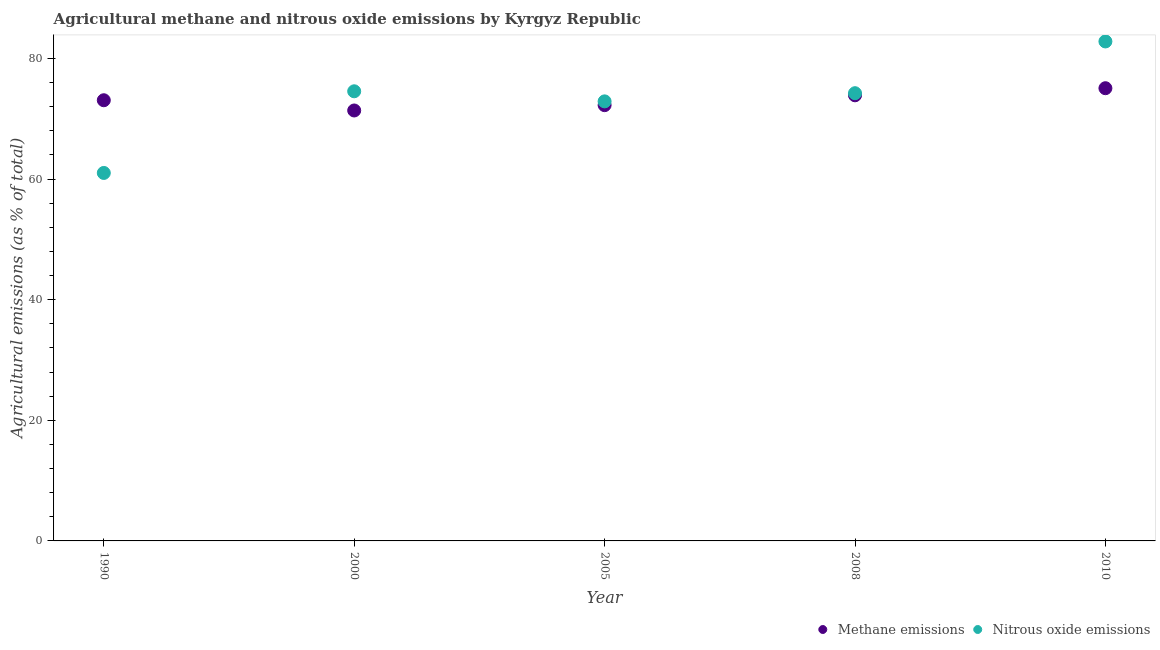Is the number of dotlines equal to the number of legend labels?
Offer a terse response. Yes. What is the amount of methane emissions in 2000?
Offer a very short reply. 71.37. Across all years, what is the maximum amount of methane emissions?
Make the answer very short. 75.07. Across all years, what is the minimum amount of nitrous oxide emissions?
Offer a very short reply. 61.01. In which year was the amount of methane emissions maximum?
Ensure brevity in your answer.  2010. What is the total amount of nitrous oxide emissions in the graph?
Your answer should be very brief. 365.51. What is the difference between the amount of methane emissions in 2005 and that in 2010?
Your answer should be very brief. -2.81. What is the difference between the amount of nitrous oxide emissions in 1990 and the amount of methane emissions in 2005?
Keep it short and to the point. -11.24. What is the average amount of nitrous oxide emissions per year?
Your response must be concise. 73.1. In the year 2010, what is the difference between the amount of methane emissions and amount of nitrous oxide emissions?
Your response must be concise. -7.75. In how many years, is the amount of methane emissions greater than 52 %?
Give a very brief answer. 5. What is the ratio of the amount of methane emissions in 1990 to that in 2000?
Provide a short and direct response. 1.02. Is the amount of methane emissions in 1990 less than that in 2010?
Offer a very short reply. Yes. Is the difference between the amount of methane emissions in 2000 and 2010 greater than the difference between the amount of nitrous oxide emissions in 2000 and 2010?
Offer a terse response. Yes. What is the difference between the highest and the second highest amount of nitrous oxide emissions?
Your response must be concise. 8.26. What is the difference between the highest and the lowest amount of nitrous oxide emissions?
Ensure brevity in your answer.  21.8. Is the sum of the amount of methane emissions in 2000 and 2008 greater than the maximum amount of nitrous oxide emissions across all years?
Offer a very short reply. Yes. How many years are there in the graph?
Provide a short and direct response. 5. Are the values on the major ticks of Y-axis written in scientific E-notation?
Offer a terse response. No. Does the graph contain grids?
Keep it short and to the point. No. How many legend labels are there?
Give a very brief answer. 2. What is the title of the graph?
Offer a very short reply. Agricultural methane and nitrous oxide emissions by Kyrgyz Republic. Does "Personal remittances" appear as one of the legend labels in the graph?
Provide a succinct answer. No. What is the label or title of the X-axis?
Make the answer very short. Year. What is the label or title of the Y-axis?
Ensure brevity in your answer.  Agricultural emissions (as % of total). What is the Agricultural emissions (as % of total) of Methane emissions in 1990?
Provide a succinct answer. 73.07. What is the Agricultural emissions (as % of total) in Nitrous oxide emissions in 1990?
Give a very brief answer. 61.01. What is the Agricultural emissions (as % of total) in Methane emissions in 2000?
Your response must be concise. 71.37. What is the Agricultural emissions (as % of total) in Nitrous oxide emissions in 2000?
Ensure brevity in your answer.  74.56. What is the Agricultural emissions (as % of total) of Methane emissions in 2005?
Your answer should be very brief. 72.26. What is the Agricultural emissions (as % of total) of Nitrous oxide emissions in 2005?
Ensure brevity in your answer.  72.88. What is the Agricultural emissions (as % of total) in Methane emissions in 2008?
Offer a terse response. 73.89. What is the Agricultural emissions (as % of total) of Nitrous oxide emissions in 2008?
Provide a short and direct response. 74.24. What is the Agricultural emissions (as % of total) of Methane emissions in 2010?
Make the answer very short. 75.07. What is the Agricultural emissions (as % of total) of Nitrous oxide emissions in 2010?
Keep it short and to the point. 82.82. Across all years, what is the maximum Agricultural emissions (as % of total) in Methane emissions?
Make the answer very short. 75.07. Across all years, what is the maximum Agricultural emissions (as % of total) of Nitrous oxide emissions?
Make the answer very short. 82.82. Across all years, what is the minimum Agricultural emissions (as % of total) in Methane emissions?
Give a very brief answer. 71.37. Across all years, what is the minimum Agricultural emissions (as % of total) in Nitrous oxide emissions?
Offer a terse response. 61.01. What is the total Agricultural emissions (as % of total) of Methane emissions in the graph?
Ensure brevity in your answer.  365.66. What is the total Agricultural emissions (as % of total) of Nitrous oxide emissions in the graph?
Provide a succinct answer. 365.51. What is the difference between the Agricultural emissions (as % of total) in Methane emissions in 1990 and that in 2000?
Provide a succinct answer. 1.7. What is the difference between the Agricultural emissions (as % of total) of Nitrous oxide emissions in 1990 and that in 2000?
Your response must be concise. -13.54. What is the difference between the Agricultural emissions (as % of total) of Methane emissions in 1990 and that in 2005?
Keep it short and to the point. 0.81. What is the difference between the Agricultural emissions (as % of total) of Nitrous oxide emissions in 1990 and that in 2005?
Make the answer very short. -11.87. What is the difference between the Agricultural emissions (as % of total) of Methane emissions in 1990 and that in 2008?
Make the answer very short. -0.82. What is the difference between the Agricultural emissions (as % of total) in Nitrous oxide emissions in 1990 and that in 2008?
Offer a very short reply. -13.22. What is the difference between the Agricultural emissions (as % of total) in Methane emissions in 1990 and that in 2010?
Offer a very short reply. -2. What is the difference between the Agricultural emissions (as % of total) of Nitrous oxide emissions in 1990 and that in 2010?
Provide a succinct answer. -21.8. What is the difference between the Agricultural emissions (as % of total) in Methane emissions in 2000 and that in 2005?
Make the answer very short. -0.89. What is the difference between the Agricultural emissions (as % of total) in Nitrous oxide emissions in 2000 and that in 2005?
Offer a very short reply. 1.67. What is the difference between the Agricultural emissions (as % of total) in Methane emissions in 2000 and that in 2008?
Give a very brief answer. -2.52. What is the difference between the Agricultural emissions (as % of total) in Nitrous oxide emissions in 2000 and that in 2008?
Ensure brevity in your answer.  0.32. What is the difference between the Agricultural emissions (as % of total) of Methane emissions in 2000 and that in 2010?
Provide a short and direct response. -3.69. What is the difference between the Agricultural emissions (as % of total) in Nitrous oxide emissions in 2000 and that in 2010?
Offer a very short reply. -8.26. What is the difference between the Agricultural emissions (as % of total) of Methane emissions in 2005 and that in 2008?
Keep it short and to the point. -1.63. What is the difference between the Agricultural emissions (as % of total) of Nitrous oxide emissions in 2005 and that in 2008?
Make the answer very short. -1.35. What is the difference between the Agricultural emissions (as % of total) of Methane emissions in 2005 and that in 2010?
Your response must be concise. -2.81. What is the difference between the Agricultural emissions (as % of total) of Nitrous oxide emissions in 2005 and that in 2010?
Your answer should be very brief. -9.93. What is the difference between the Agricultural emissions (as % of total) in Methane emissions in 2008 and that in 2010?
Your response must be concise. -1.18. What is the difference between the Agricultural emissions (as % of total) in Nitrous oxide emissions in 2008 and that in 2010?
Provide a succinct answer. -8.58. What is the difference between the Agricultural emissions (as % of total) in Methane emissions in 1990 and the Agricultural emissions (as % of total) in Nitrous oxide emissions in 2000?
Your answer should be compact. -1.49. What is the difference between the Agricultural emissions (as % of total) in Methane emissions in 1990 and the Agricultural emissions (as % of total) in Nitrous oxide emissions in 2005?
Ensure brevity in your answer.  0.19. What is the difference between the Agricultural emissions (as % of total) of Methane emissions in 1990 and the Agricultural emissions (as % of total) of Nitrous oxide emissions in 2008?
Ensure brevity in your answer.  -1.17. What is the difference between the Agricultural emissions (as % of total) in Methane emissions in 1990 and the Agricultural emissions (as % of total) in Nitrous oxide emissions in 2010?
Give a very brief answer. -9.75. What is the difference between the Agricultural emissions (as % of total) in Methane emissions in 2000 and the Agricultural emissions (as % of total) in Nitrous oxide emissions in 2005?
Your answer should be very brief. -1.51. What is the difference between the Agricultural emissions (as % of total) in Methane emissions in 2000 and the Agricultural emissions (as % of total) in Nitrous oxide emissions in 2008?
Your answer should be very brief. -2.87. What is the difference between the Agricultural emissions (as % of total) in Methane emissions in 2000 and the Agricultural emissions (as % of total) in Nitrous oxide emissions in 2010?
Your answer should be very brief. -11.45. What is the difference between the Agricultural emissions (as % of total) in Methane emissions in 2005 and the Agricultural emissions (as % of total) in Nitrous oxide emissions in 2008?
Keep it short and to the point. -1.98. What is the difference between the Agricultural emissions (as % of total) of Methane emissions in 2005 and the Agricultural emissions (as % of total) of Nitrous oxide emissions in 2010?
Make the answer very short. -10.56. What is the difference between the Agricultural emissions (as % of total) in Methane emissions in 2008 and the Agricultural emissions (as % of total) in Nitrous oxide emissions in 2010?
Offer a terse response. -8.93. What is the average Agricultural emissions (as % of total) of Methane emissions per year?
Your response must be concise. 73.13. What is the average Agricultural emissions (as % of total) of Nitrous oxide emissions per year?
Offer a very short reply. 73.1. In the year 1990, what is the difference between the Agricultural emissions (as % of total) in Methane emissions and Agricultural emissions (as % of total) in Nitrous oxide emissions?
Your answer should be compact. 12.06. In the year 2000, what is the difference between the Agricultural emissions (as % of total) in Methane emissions and Agricultural emissions (as % of total) in Nitrous oxide emissions?
Your response must be concise. -3.18. In the year 2005, what is the difference between the Agricultural emissions (as % of total) of Methane emissions and Agricultural emissions (as % of total) of Nitrous oxide emissions?
Provide a succinct answer. -0.63. In the year 2008, what is the difference between the Agricultural emissions (as % of total) in Methane emissions and Agricultural emissions (as % of total) in Nitrous oxide emissions?
Keep it short and to the point. -0.35. In the year 2010, what is the difference between the Agricultural emissions (as % of total) in Methane emissions and Agricultural emissions (as % of total) in Nitrous oxide emissions?
Ensure brevity in your answer.  -7.75. What is the ratio of the Agricultural emissions (as % of total) in Methane emissions in 1990 to that in 2000?
Offer a terse response. 1.02. What is the ratio of the Agricultural emissions (as % of total) of Nitrous oxide emissions in 1990 to that in 2000?
Provide a short and direct response. 0.82. What is the ratio of the Agricultural emissions (as % of total) in Methane emissions in 1990 to that in 2005?
Provide a succinct answer. 1.01. What is the ratio of the Agricultural emissions (as % of total) of Nitrous oxide emissions in 1990 to that in 2005?
Your answer should be compact. 0.84. What is the ratio of the Agricultural emissions (as % of total) of Methane emissions in 1990 to that in 2008?
Provide a succinct answer. 0.99. What is the ratio of the Agricultural emissions (as % of total) in Nitrous oxide emissions in 1990 to that in 2008?
Offer a terse response. 0.82. What is the ratio of the Agricultural emissions (as % of total) of Methane emissions in 1990 to that in 2010?
Provide a succinct answer. 0.97. What is the ratio of the Agricultural emissions (as % of total) of Nitrous oxide emissions in 1990 to that in 2010?
Give a very brief answer. 0.74. What is the ratio of the Agricultural emissions (as % of total) in Nitrous oxide emissions in 2000 to that in 2005?
Keep it short and to the point. 1.02. What is the ratio of the Agricultural emissions (as % of total) of Methane emissions in 2000 to that in 2008?
Your response must be concise. 0.97. What is the ratio of the Agricultural emissions (as % of total) of Nitrous oxide emissions in 2000 to that in 2008?
Ensure brevity in your answer.  1. What is the ratio of the Agricultural emissions (as % of total) of Methane emissions in 2000 to that in 2010?
Ensure brevity in your answer.  0.95. What is the ratio of the Agricultural emissions (as % of total) of Nitrous oxide emissions in 2000 to that in 2010?
Provide a short and direct response. 0.9. What is the ratio of the Agricultural emissions (as % of total) in Methane emissions in 2005 to that in 2008?
Your answer should be compact. 0.98. What is the ratio of the Agricultural emissions (as % of total) in Nitrous oxide emissions in 2005 to that in 2008?
Offer a terse response. 0.98. What is the ratio of the Agricultural emissions (as % of total) of Methane emissions in 2005 to that in 2010?
Give a very brief answer. 0.96. What is the ratio of the Agricultural emissions (as % of total) in Nitrous oxide emissions in 2005 to that in 2010?
Give a very brief answer. 0.88. What is the ratio of the Agricultural emissions (as % of total) in Methane emissions in 2008 to that in 2010?
Keep it short and to the point. 0.98. What is the ratio of the Agricultural emissions (as % of total) in Nitrous oxide emissions in 2008 to that in 2010?
Offer a very short reply. 0.9. What is the difference between the highest and the second highest Agricultural emissions (as % of total) in Methane emissions?
Give a very brief answer. 1.18. What is the difference between the highest and the second highest Agricultural emissions (as % of total) in Nitrous oxide emissions?
Provide a short and direct response. 8.26. What is the difference between the highest and the lowest Agricultural emissions (as % of total) in Methane emissions?
Your response must be concise. 3.69. What is the difference between the highest and the lowest Agricultural emissions (as % of total) of Nitrous oxide emissions?
Provide a succinct answer. 21.8. 